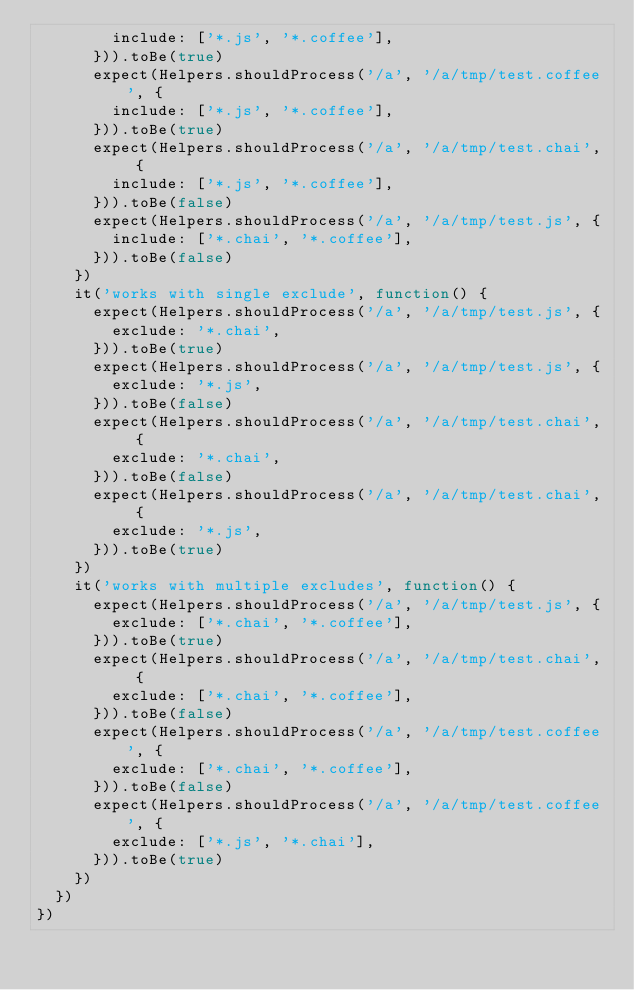Convert code to text. <code><loc_0><loc_0><loc_500><loc_500><_JavaScript_>        include: ['*.js', '*.coffee'],
      })).toBe(true)
      expect(Helpers.shouldProcess('/a', '/a/tmp/test.coffee', {
        include: ['*.js', '*.coffee'],
      })).toBe(true)
      expect(Helpers.shouldProcess('/a', '/a/tmp/test.chai', {
        include: ['*.js', '*.coffee'],
      })).toBe(false)
      expect(Helpers.shouldProcess('/a', '/a/tmp/test.js', {
        include: ['*.chai', '*.coffee'],
      })).toBe(false)
    })
    it('works with single exclude', function() {
      expect(Helpers.shouldProcess('/a', '/a/tmp/test.js', {
        exclude: '*.chai',
      })).toBe(true)
      expect(Helpers.shouldProcess('/a', '/a/tmp/test.js', {
        exclude: '*.js',
      })).toBe(false)
      expect(Helpers.shouldProcess('/a', '/a/tmp/test.chai', {
        exclude: '*.chai',
      })).toBe(false)
      expect(Helpers.shouldProcess('/a', '/a/tmp/test.chai', {
        exclude: '*.js',
      })).toBe(true)
    })
    it('works with multiple excludes', function() {
      expect(Helpers.shouldProcess('/a', '/a/tmp/test.js', {
        exclude: ['*.chai', '*.coffee'],
      })).toBe(true)
      expect(Helpers.shouldProcess('/a', '/a/tmp/test.chai', {
        exclude: ['*.chai', '*.coffee'],
      })).toBe(false)
      expect(Helpers.shouldProcess('/a', '/a/tmp/test.coffee', {
        exclude: ['*.chai', '*.coffee'],
      })).toBe(false)
      expect(Helpers.shouldProcess('/a', '/a/tmp/test.coffee', {
        exclude: ['*.js', '*.chai'],
      })).toBe(true)
    })
  })
})
</code> 